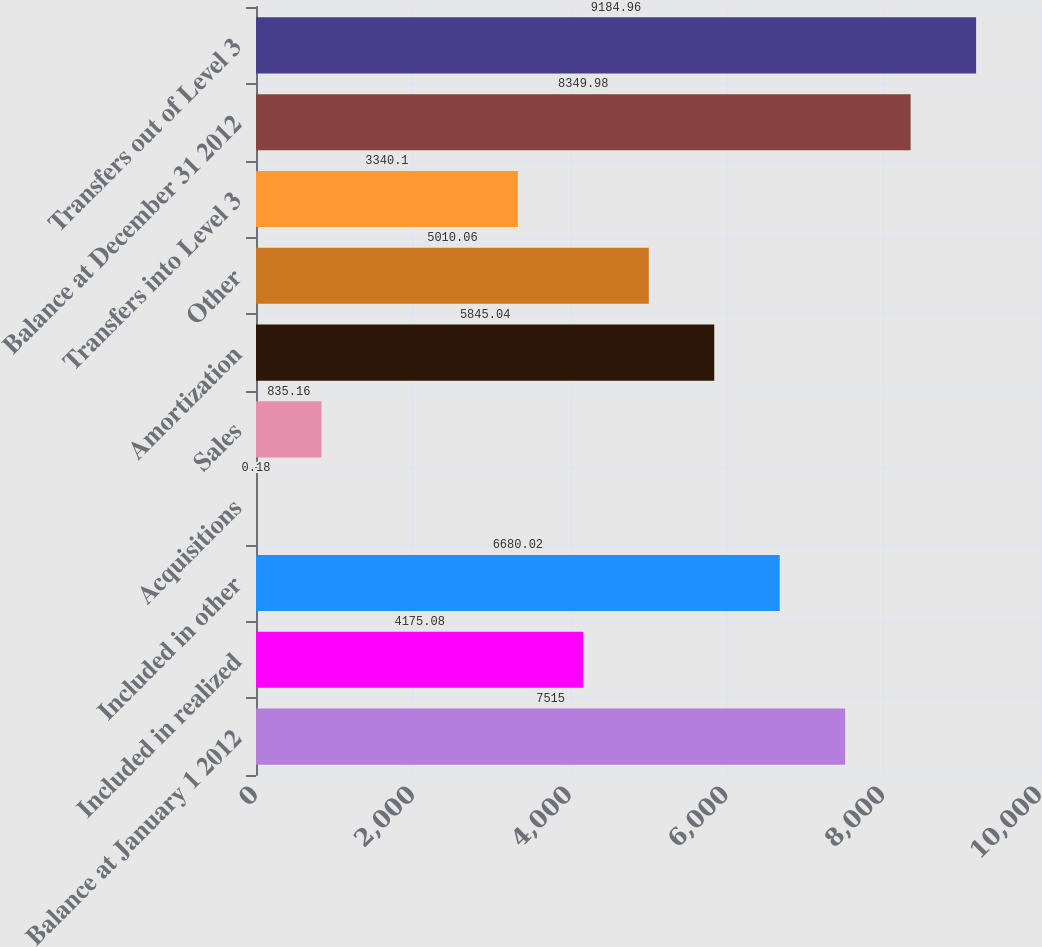<chart> <loc_0><loc_0><loc_500><loc_500><bar_chart><fcel>Balance at January 1 2012<fcel>Included in realized<fcel>Included in other<fcel>Acquisitions<fcel>Sales<fcel>Amortization<fcel>Other<fcel>Transfers into Level 3<fcel>Balance at December 31 2012<fcel>Transfers out of Level 3<nl><fcel>7515<fcel>4175.08<fcel>6680.02<fcel>0.18<fcel>835.16<fcel>5845.04<fcel>5010.06<fcel>3340.1<fcel>8349.98<fcel>9184.96<nl></chart> 